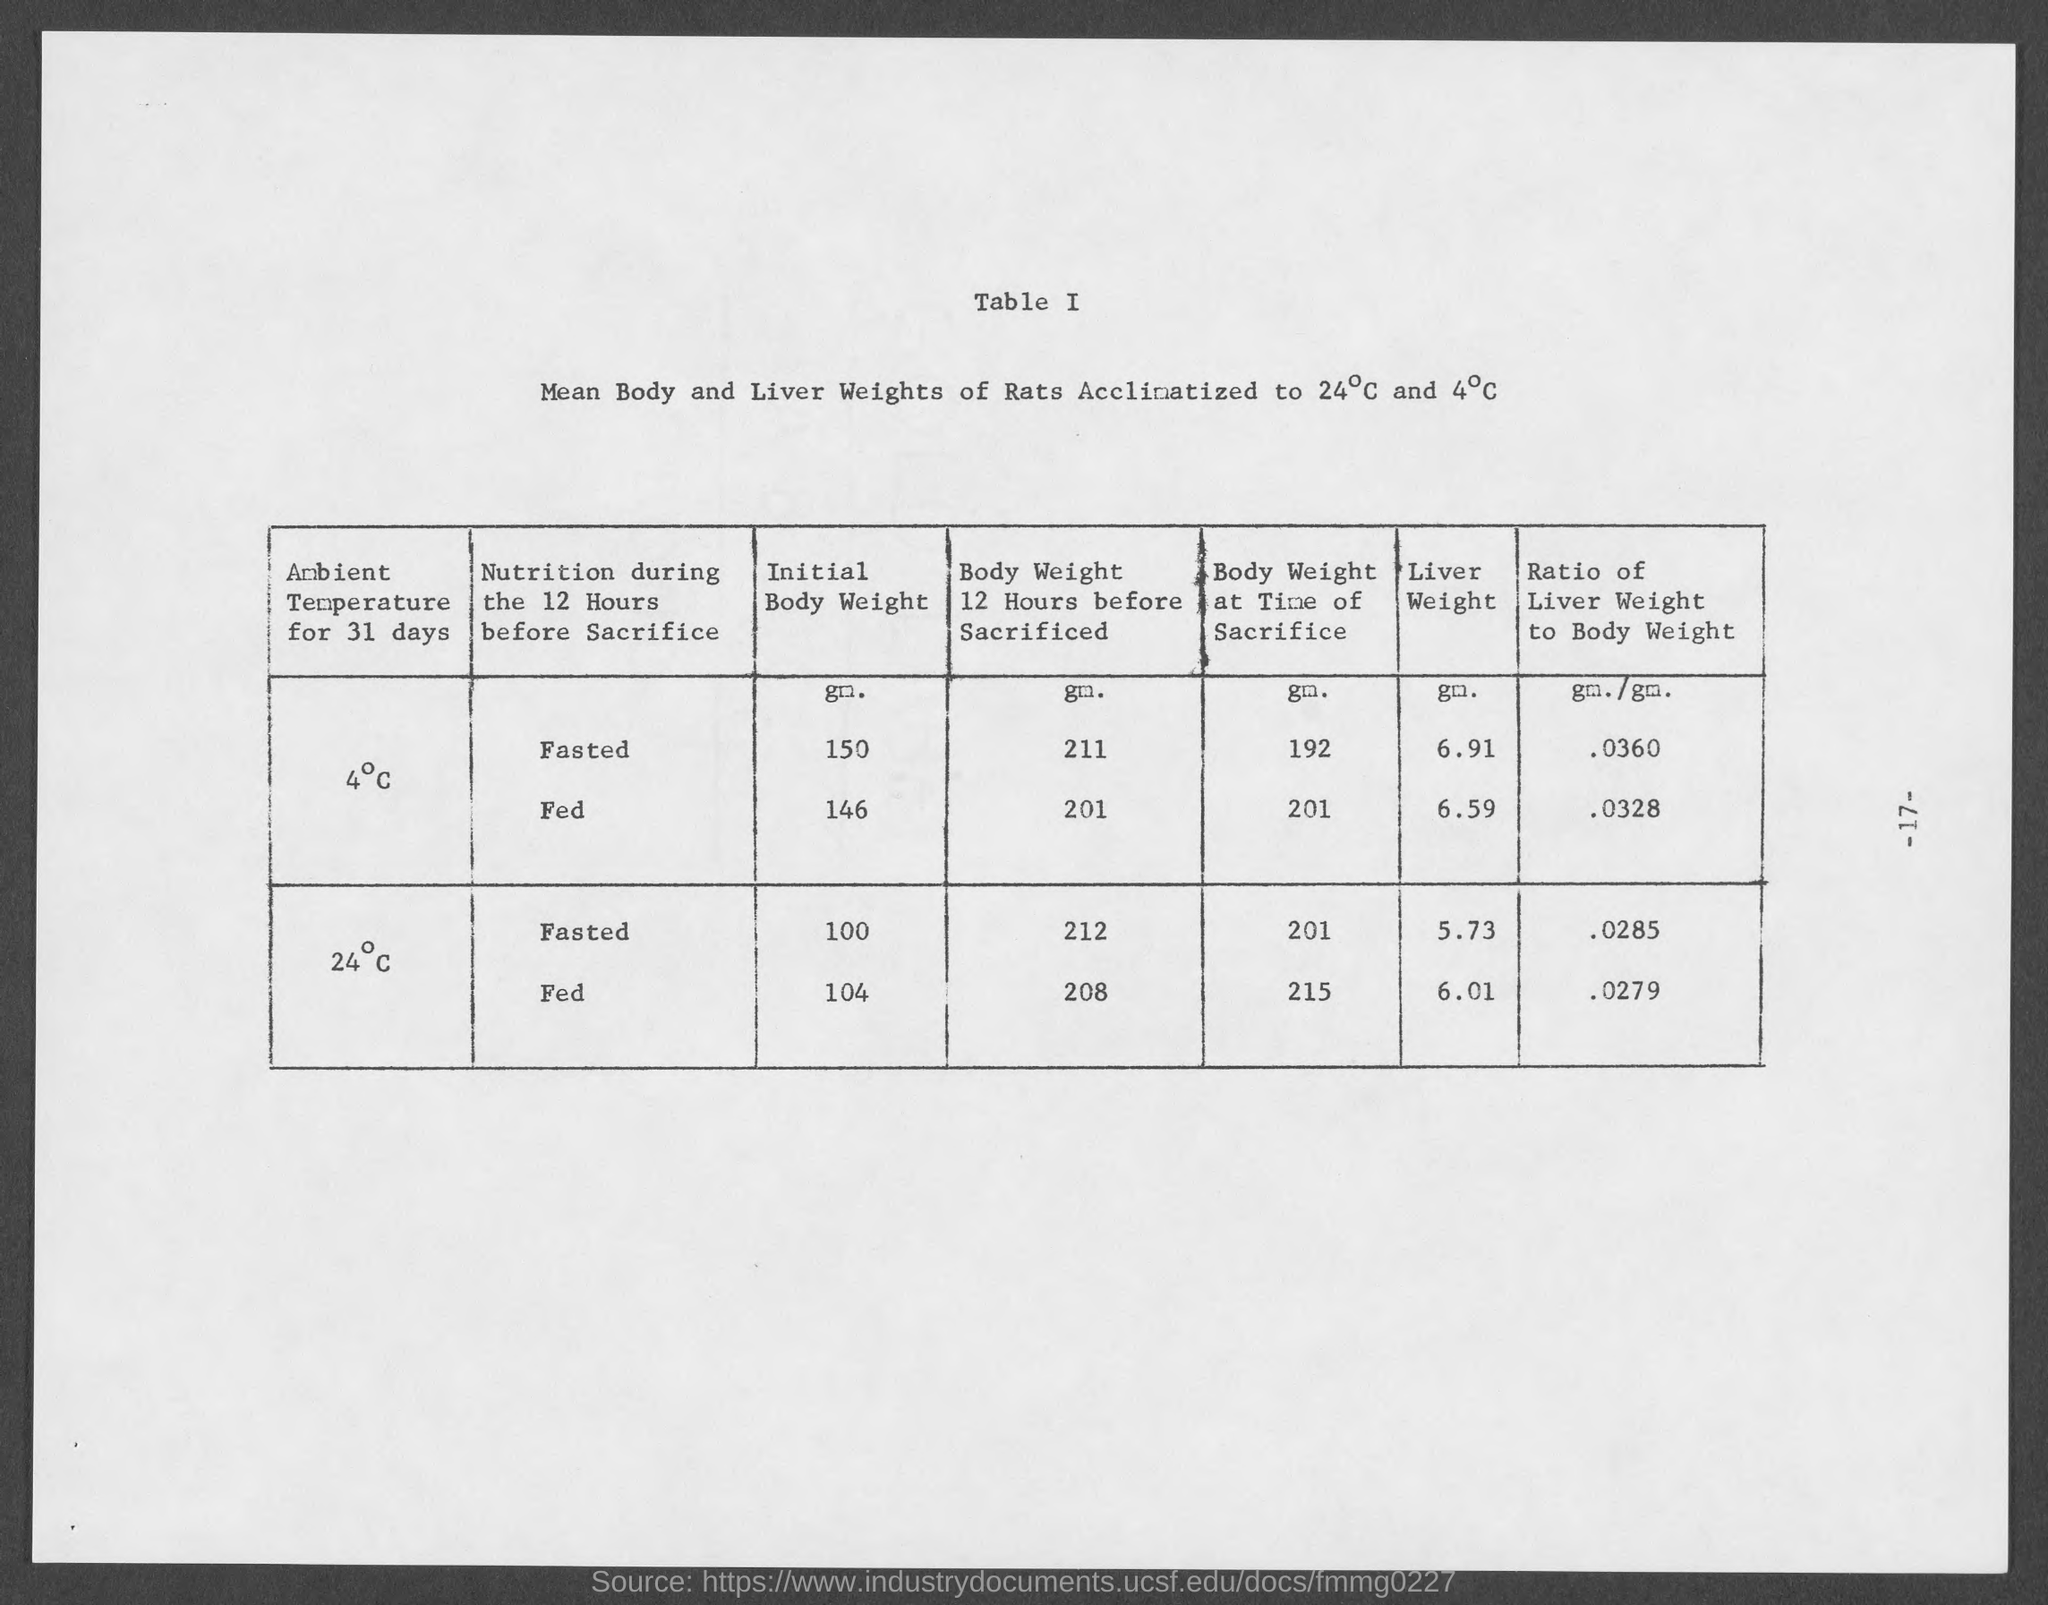Highlight a few significant elements in this photo. The weight of the liver of fasted rats that have become acclimated to 24 degrees Celsius is 5.73 grams. 